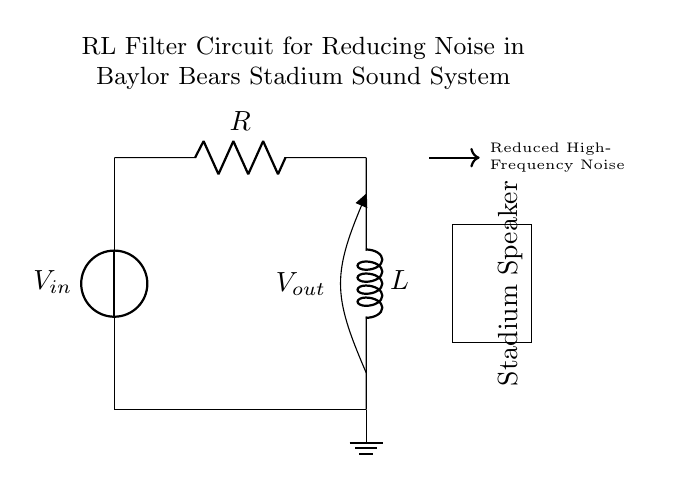What is the input voltage in this circuit? The input voltage, denoted as V-in, is represented at the top left of the circuit diagram, showing the connection to the voltage source.
Answer: V-in What components are part of the circuit? The circuit includes a voltage source, a resistor labeled R, and an inductor labeled L. These components are connected in a series configuration.
Answer: Voltage source, resistor, inductor What type of filter is represented by this circuit? This circuit is an RL filter circuit, which is identified by having a resistor and an inductor in series used for reducing high-frequency noise.
Answer: RL filter What does the arrow indicate in the circuit? The arrow pointing to the output indicates that the circuit reduces high-frequency noise, which is a critical function of the filter in this context.
Answer: Reduced high-frequency noise How does the inductor affect the circuit operation? The inductor acts to oppose changes in current, resulting in the filtering effect necessary to reduce noise within the sound system by allowing only lower frequencies to pass.
Answer: Opposes current changes What is the output voltage labeled as in the circuit? The output voltage is labeled as V-out, which indicates the voltage at the output of the circuit after the filtering process takes place.
Answer: V-out 